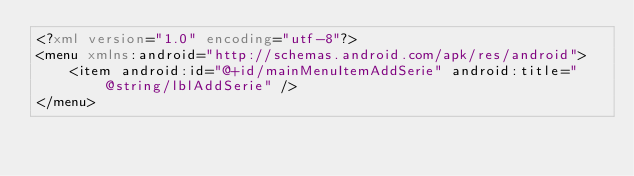<code> <loc_0><loc_0><loc_500><loc_500><_XML_><?xml version="1.0" encoding="utf-8"?>
<menu xmlns:android="http://schemas.android.com/apk/res/android">
    <item android:id="@+id/mainMenuItemAddSerie" android:title="@string/lblAddSerie" />
</menu></code> 